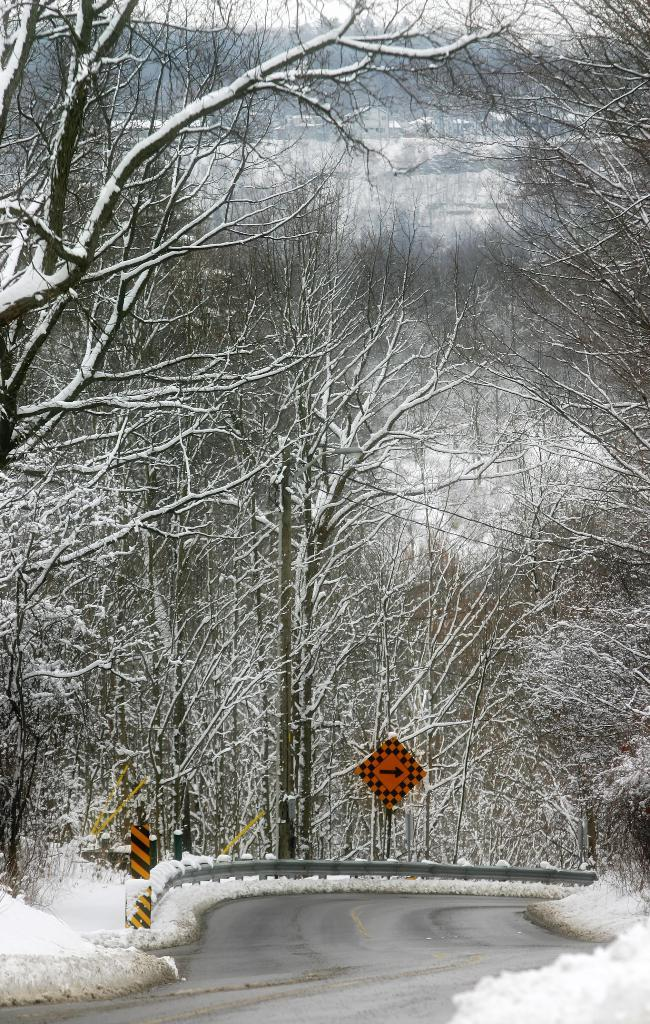What is the main feature of the image? There is a road in the image. What is the condition of the environment surrounding the road? There is snow on either side of the road. What can be seen in the distance in the image? There are trees in the background of the image. How many boxes can be seen stacked on the arm of the person in the image? There is no person or box present in the image; it features a road with snow on either side and trees in the background. 